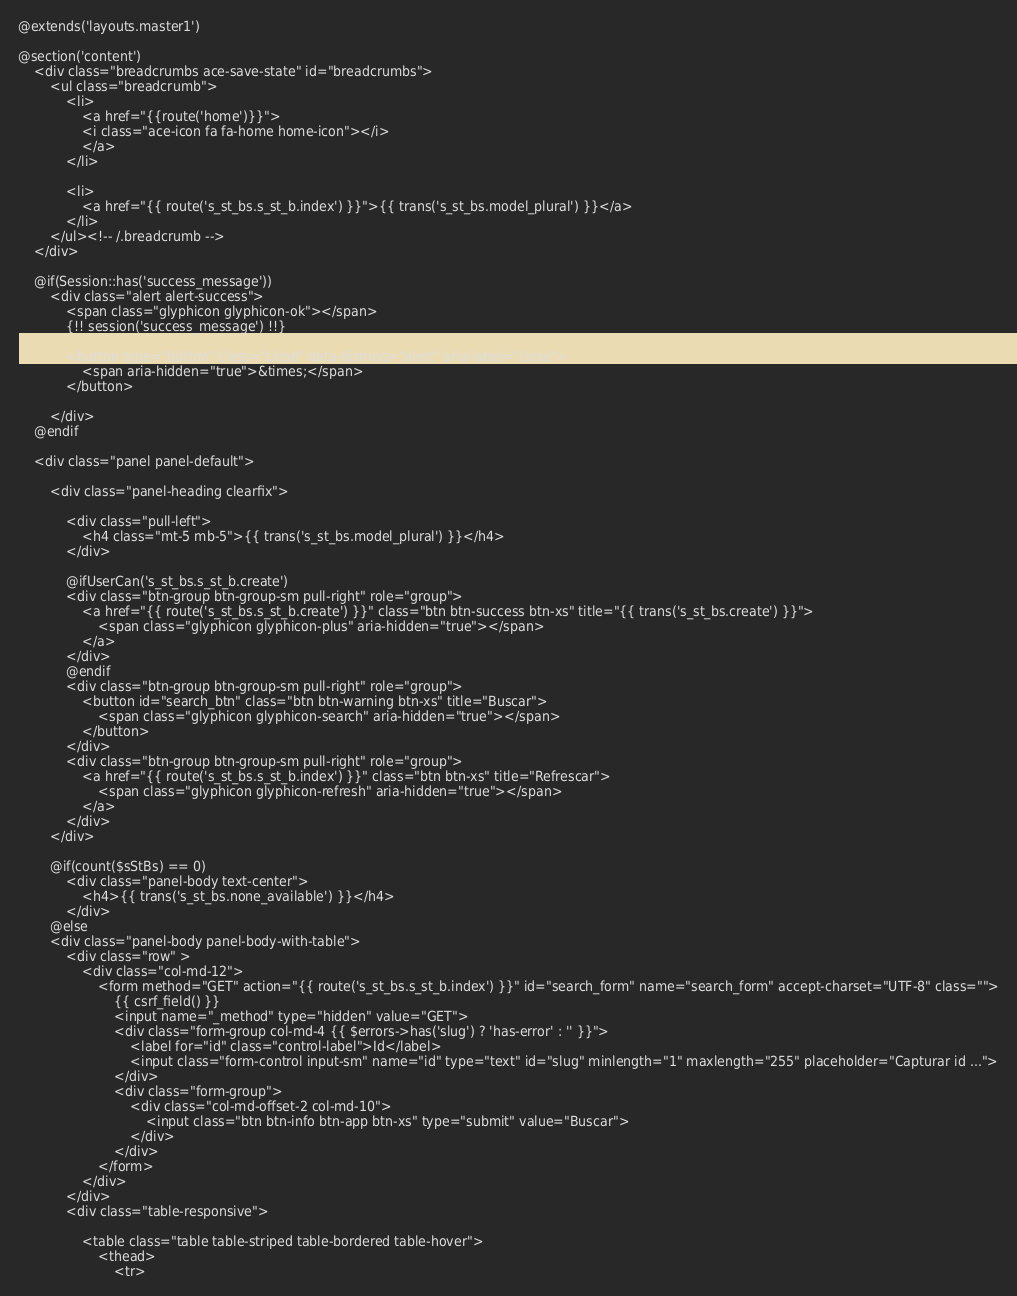<code> <loc_0><loc_0><loc_500><loc_500><_PHP_>@extends('layouts.master1')

@section('content')
	<div class="breadcrumbs ace-save-state" id="breadcrumbs">
		<ul class="breadcrumb">
			<li>
				<a href="{{route('home')}}">
				<i class="ace-icon fa fa-home home-icon"></i>
				</a>
			</li>

			<li>
				<a href="{{ route('s_st_bs.s_st_b.index') }}">{{ trans('s_st_bs.model_plural') }}</a>
			</li>
		</ul><!-- /.breadcrumb -->
	</div>

    @if(Session::has('success_message'))
        <div class="alert alert-success">
            <span class="glyphicon glyphicon-ok"></span>
            {!! session('success_message') !!}

            <button type="button" class="close" data-dismiss="alert" aria-label="close">
                <span aria-hidden="true">&times;</span>
            </button>

        </div>
    @endif
	
    <div class="panel panel-default">

        <div class="panel-heading clearfix">

            <div class="pull-left">
                <h4 class="mt-5 mb-5">{{ trans('s_st_bs.model_plural') }}</h4>
            </div>
            
            @ifUserCan('s_st_bs.s_st_b.create')
            <div class="btn-group btn-group-sm pull-right" role="group">
                <a href="{{ route('s_st_bs.s_st_b.create') }}" class="btn btn-success btn-xs" title="{{ trans('s_st_bs.create') }}">
                    <span class="glyphicon glyphicon-plus" aria-hidden="true"></span>
                </a>
            </div>
            @endif
			<div class="btn-group btn-group-sm pull-right" role="group">
                <button id="search_btn" class="btn btn-warning btn-xs" title="Buscar">
					<span class="glyphicon glyphicon-search" aria-hidden="true"></span>
				</button>
            </div>
			<div class="btn-group btn-group-sm pull-right" role="group">
                <a href="{{ route('s_st_bs.s_st_b.index') }}" class="btn btn-xs" title="Refrescar">
                    <span class="glyphicon glyphicon-refresh" aria-hidden="true"></span>
                </a>
            </div>
        </div>
        
        @if(count($sStBs) == 0)
            <div class="panel-body text-center">
                <h4>{{ trans('s_st_bs.none_available') }}</h4>
            </div>
        @else
        <div class="panel-body panel-body-with-table">
            <div class="row" >
				<div class="col-md-12">
					<form method="GET" action="{{ route('s_st_bs.s_st_b.index') }}" id="search_form" name="search_form" accept-charset="UTF-8" class="">
						{{ csrf_field() }}
						<input name="_method" type="hidden" value="GET">
						<div class="form-group col-md-4 {{ $errors->has('slug') ? 'has-error' : '' }}">
							<label for="id" class="control-label">Id</label>
							<input class="form-control input-sm" name="id" type="text" id="slug" minlength="1" maxlength="255" placeholder="Capturar id ...">
						</div>
						<div class="form-group">
							<div class="col-md-offset-2 col-md-10">
								<input class="btn btn-info btn-app btn-xs" type="submit" value="Buscar">
							</div>
						</div>
					</form>
				</div>
			</div>
			<div class="table-responsive">

                <table class="table table-striped table-bordered table-hover">
                    <thead>
                        <tr></code> 